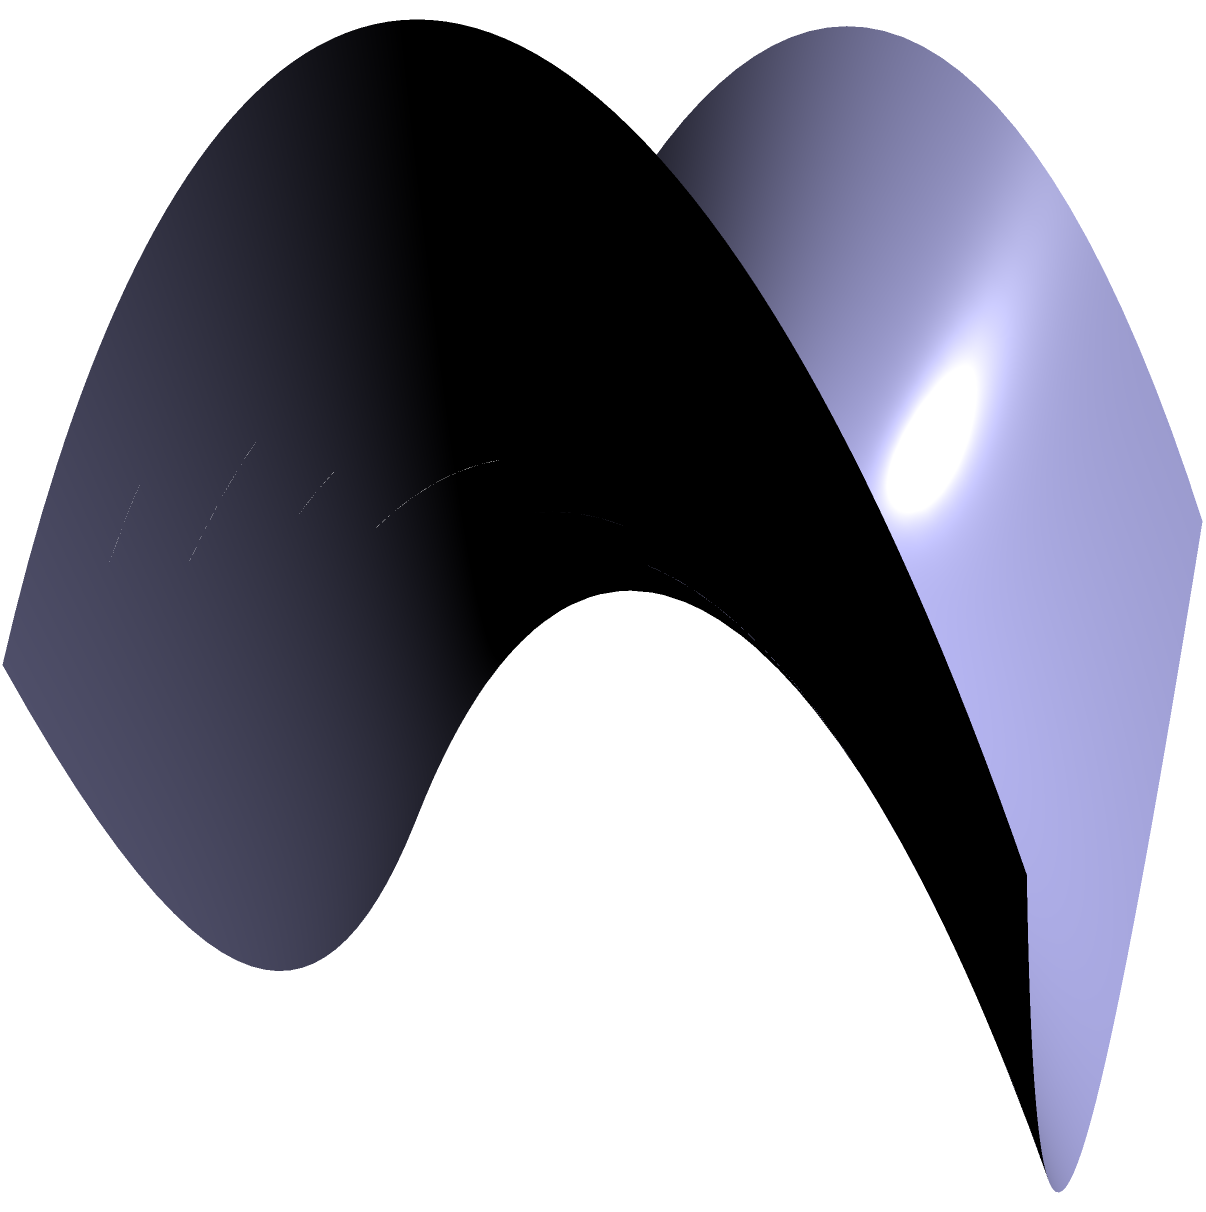In the context of a peaceful resolution to the conflict, consider two lines on a saddle-shaped surface (hyperbolic paraboloid) as shown in the diagram. If these lines appear to intersect when viewed from above, what can we conclude about their relationship in the non-Euclidean geometry of this surface? To understand this concept, let's break it down step-by-step:

1. The surface shown is a hyperbolic paraboloid, which is a saddle-shaped surface common in non-Euclidean geometry.

2. In Euclidean geometry, parallel lines never intersect. However, on curved surfaces like this, the rules change.

3. The red and blue lines on the surface appear to intersect when viewed from above, but they don't actually touch on the surface itself.

4. In non-Euclidean geometry, specifically on a hyperbolic surface:
   a) Parallel lines can diverge from each other.
   b) Lines that appear to intersect from one perspective may not actually meet on the surface.

5. The lines shown are examples of "ultraparallel" lines in hyperbolic geometry. They are:
   a) Neither intersecting (as they would in Euclidean geometry)
   b) Nor asymptotic (approaching each other at infinity)

6. This concept demonstrates that in the geometry of peace-seeking, seemingly conflicting paths (like those of opposing factions) may not actually intersect or clash when viewed from a different perspective.

Therefore, we can conclude that these lines, despite appearing to intersect from above, are actually ultraparallel in the non-Euclidean geometry of this saddle-shaped surface.
Answer: Ultraparallel 